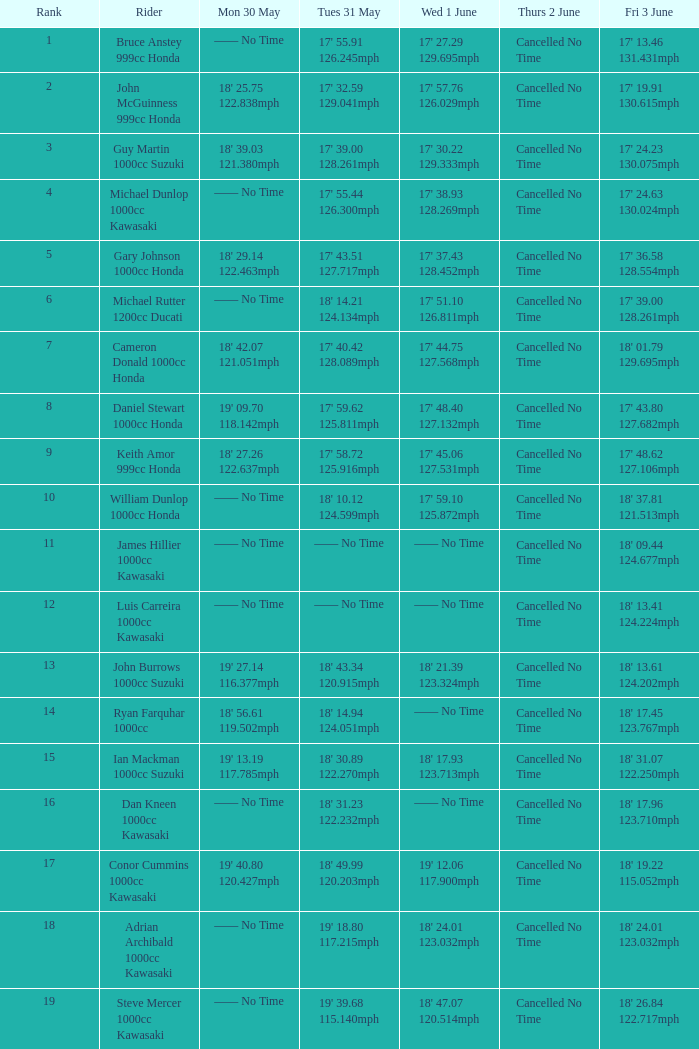What is the Mon 30 May time for the rider whose Fri 3 June time was 17' 13.46 131.431mph? —— No Time. 